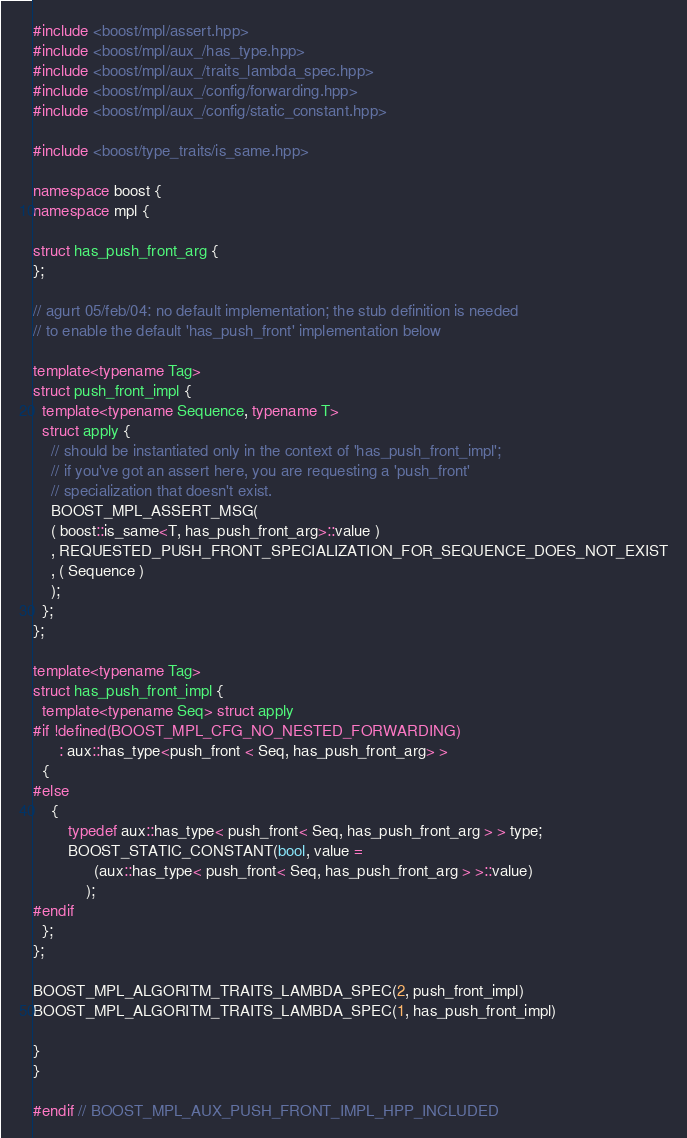Convert code to text. <code><loc_0><loc_0><loc_500><loc_500><_C++_>#include <boost/mpl/assert.hpp>
#include <boost/mpl/aux_/has_type.hpp>
#include <boost/mpl/aux_/traits_lambda_spec.hpp>
#include <boost/mpl/aux_/config/forwarding.hpp>
#include <boost/mpl/aux_/config/static_constant.hpp>

#include <boost/type_traits/is_same.hpp>

namespace boost {
namespace mpl {

struct has_push_front_arg {
};

// agurt 05/feb/04: no default implementation; the stub definition is needed 
// to enable the default 'has_push_front' implementation below

template<typename Tag>
struct push_front_impl {
  template<typename Sequence, typename T>
  struct apply {
    // should be instantiated only in the context of 'has_push_front_impl';
    // if you've got an assert here, you are requesting a 'push_front'
    // specialization that doesn't exist.
    BOOST_MPL_ASSERT_MSG(
    ( boost::is_same<T, has_push_front_arg>::value )
    , REQUESTED_PUSH_FRONT_SPECIALIZATION_FOR_SEQUENCE_DOES_NOT_EXIST
    , ( Sequence )
    );
  };
};

template<typename Tag>
struct has_push_front_impl {
  template<typename Seq> struct apply
#if !defined(BOOST_MPL_CFG_NO_NESTED_FORWARDING)
      : aux::has_type<push_front < Seq, has_push_front_arg> >
  {
#else
    {
        typedef aux::has_type< push_front< Seq, has_push_front_arg > > type;
        BOOST_STATIC_CONSTANT(bool, value = 
              (aux::has_type< push_front< Seq, has_push_front_arg > >::value)
            );
#endif
  };
};

BOOST_MPL_ALGORITM_TRAITS_LAMBDA_SPEC(2, push_front_impl)
BOOST_MPL_ALGORITM_TRAITS_LAMBDA_SPEC(1, has_push_front_impl)

}
}

#endif // BOOST_MPL_AUX_PUSH_FRONT_IMPL_HPP_INCLUDED
</code> 